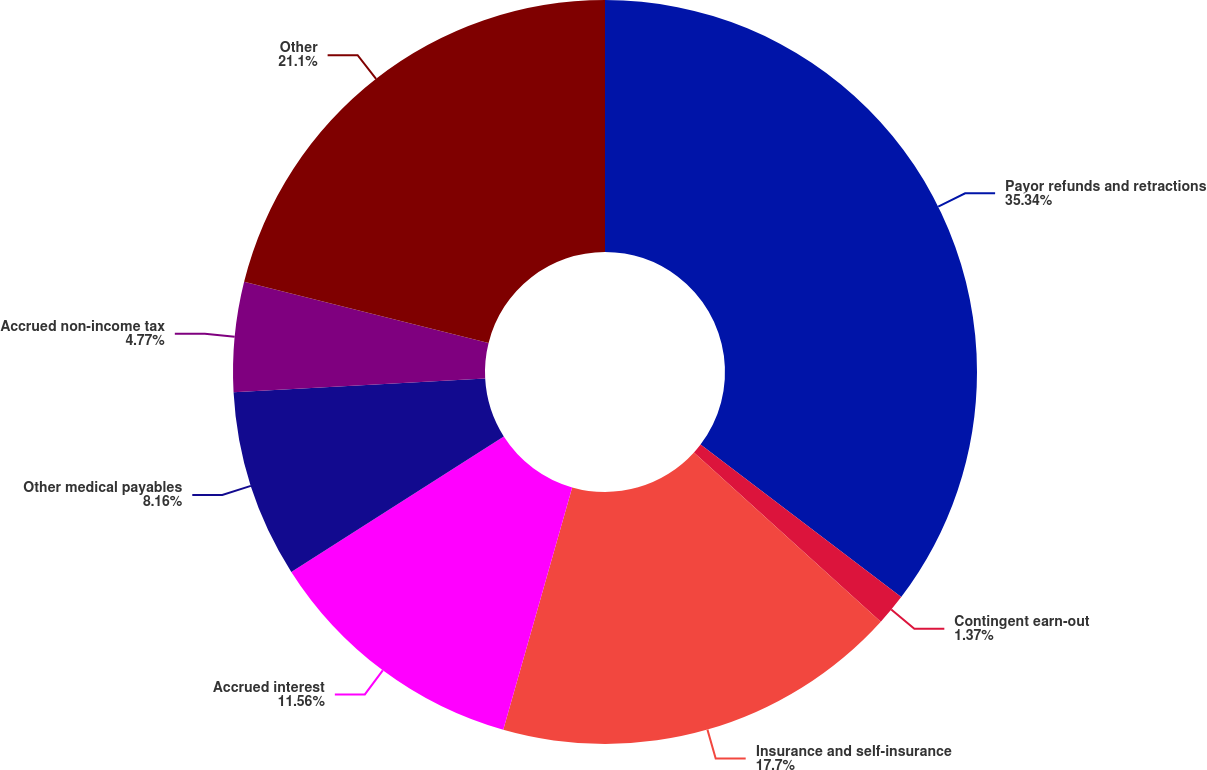Convert chart. <chart><loc_0><loc_0><loc_500><loc_500><pie_chart><fcel>Payor refunds and retractions<fcel>Contingent earn-out<fcel>Insurance and self-insurance<fcel>Accrued interest<fcel>Other medical payables<fcel>Accrued non-income tax<fcel>Other<nl><fcel>35.34%<fcel>1.37%<fcel>17.7%<fcel>11.56%<fcel>8.16%<fcel>4.77%<fcel>21.1%<nl></chart> 